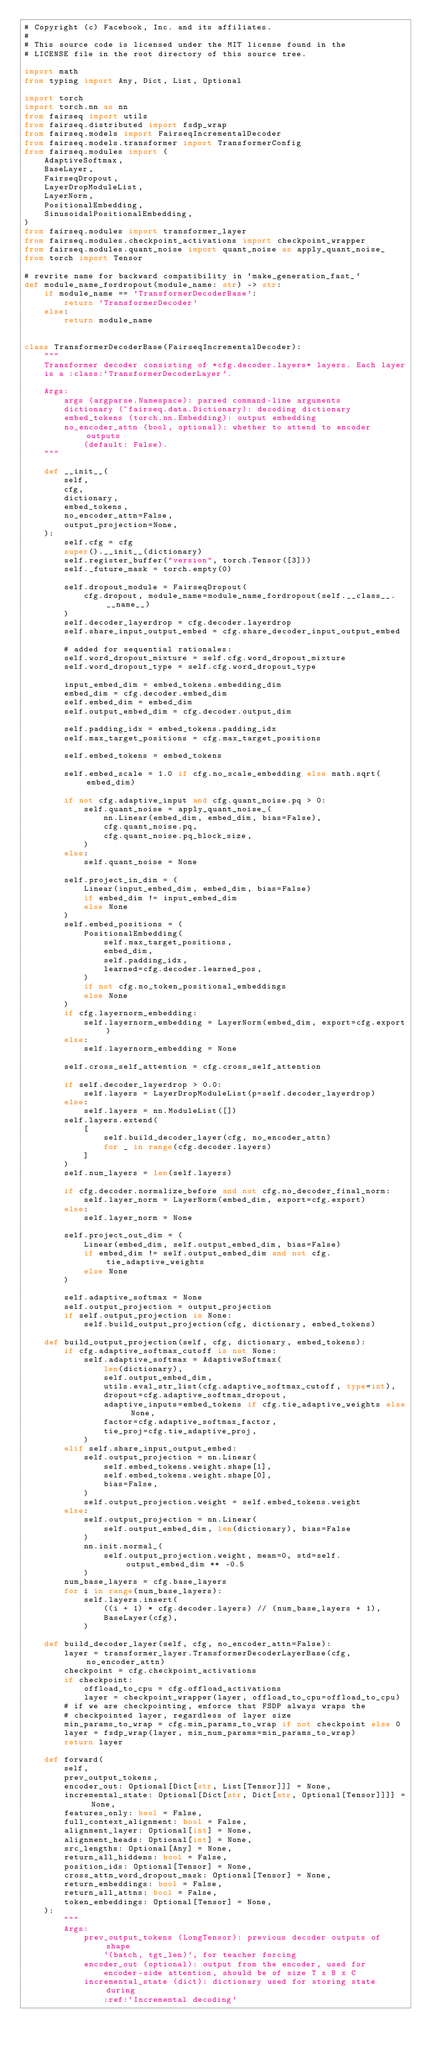<code> <loc_0><loc_0><loc_500><loc_500><_Python_># Copyright (c) Facebook, Inc. and its affiliates.
#
# This source code is licensed under the MIT license found in the
# LICENSE file in the root directory of this source tree.

import math
from typing import Any, Dict, List, Optional

import torch
import torch.nn as nn
from fairseq import utils
from fairseq.distributed import fsdp_wrap
from fairseq.models import FairseqIncrementalDecoder
from fairseq.models.transformer import TransformerConfig
from fairseq.modules import (
    AdaptiveSoftmax,
    BaseLayer,
    FairseqDropout,
    LayerDropModuleList,
    LayerNorm,
    PositionalEmbedding,
    SinusoidalPositionalEmbedding,
)
from fairseq.modules import transformer_layer
from fairseq.modules.checkpoint_activations import checkpoint_wrapper
from fairseq.modules.quant_noise import quant_noise as apply_quant_noise_
from torch import Tensor

# rewrite name for backward compatibility in `make_generation_fast_`
def module_name_fordropout(module_name: str) -> str:
    if module_name == 'TransformerDecoderBase':
        return 'TransformerDecoder'
    else:
        return module_name


class TransformerDecoderBase(FairseqIncrementalDecoder):
    """
    Transformer decoder consisting of *cfg.decoder.layers* layers. Each layer
    is a :class:`TransformerDecoderLayer`.

    Args:
        args (argparse.Namespace): parsed command-line arguments
        dictionary (~fairseq.data.Dictionary): decoding dictionary
        embed_tokens (torch.nn.Embedding): output embedding
        no_encoder_attn (bool, optional): whether to attend to encoder outputs
            (default: False).
    """

    def __init__(
        self,
        cfg,
        dictionary,
        embed_tokens,
        no_encoder_attn=False,
        output_projection=None,
    ):
        self.cfg = cfg
        super().__init__(dictionary)
        self.register_buffer("version", torch.Tensor([3]))
        self._future_mask = torch.empty(0)

        self.dropout_module = FairseqDropout(
            cfg.dropout, module_name=module_name_fordropout(self.__class__.__name__)
        )
        self.decoder_layerdrop = cfg.decoder.layerdrop
        self.share_input_output_embed = cfg.share_decoder_input_output_embed

        # added for sequential rationales:
        self.word_dropout_mixture = self.cfg.word_dropout_mixture
        self.word_dropout_type = self.cfg.word_dropout_type

        input_embed_dim = embed_tokens.embedding_dim
        embed_dim = cfg.decoder.embed_dim
        self.embed_dim = embed_dim
        self.output_embed_dim = cfg.decoder.output_dim

        self.padding_idx = embed_tokens.padding_idx
        self.max_target_positions = cfg.max_target_positions

        self.embed_tokens = embed_tokens

        self.embed_scale = 1.0 if cfg.no_scale_embedding else math.sqrt(embed_dim)

        if not cfg.adaptive_input and cfg.quant_noise.pq > 0:
            self.quant_noise = apply_quant_noise_(
                nn.Linear(embed_dim, embed_dim, bias=False),
                cfg.quant_noise.pq,
                cfg.quant_noise.pq_block_size,
            )
        else:
            self.quant_noise = None

        self.project_in_dim = (
            Linear(input_embed_dim, embed_dim, bias=False)
            if embed_dim != input_embed_dim
            else None
        )
        self.embed_positions = (
            PositionalEmbedding(
                self.max_target_positions,
                embed_dim,
                self.padding_idx,
                learned=cfg.decoder.learned_pos,
            )
            if not cfg.no_token_positional_embeddings
            else None
        )
        if cfg.layernorm_embedding:
            self.layernorm_embedding = LayerNorm(embed_dim, export=cfg.export)
        else:
            self.layernorm_embedding = None

        self.cross_self_attention = cfg.cross_self_attention

        if self.decoder_layerdrop > 0.0:
            self.layers = LayerDropModuleList(p=self.decoder_layerdrop)
        else:
            self.layers = nn.ModuleList([])
        self.layers.extend(
            [
                self.build_decoder_layer(cfg, no_encoder_attn)
                for _ in range(cfg.decoder.layers)
            ]
        )
        self.num_layers = len(self.layers)

        if cfg.decoder.normalize_before and not cfg.no_decoder_final_norm:
            self.layer_norm = LayerNorm(embed_dim, export=cfg.export)
        else:
            self.layer_norm = None

        self.project_out_dim = (
            Linear(embed_dim, self.output_embed_dim, bias=False)
            if embed_dim != self.output_embed_dim and not cfg.tie_adaptive_weights
            else None
        )

        self.adaptive_softmax = None
        self.output_projection = output_projection
        if self.output_projection is None:
            self.build_output_projection(cfg, dictionary, embed_tokens)

    def build_output_projection(self, cfg, dictionary, embed_tokens):
        if cfg.adaptive_softmax_cutoff is not None:
            self.adaptive_softmax = AdaptiveSoftmax(
                len(dictionary),
                self.output_embed_dim,
                utils.eval_str_list(cfg.adaptive_softmax_cutoff, type=int),
                dropout=cfg.adaptive_softmax_dropout,
                adaptive_inputs=embed_tokens if cfg.tie_adaptive_weights else None,
                factor=cfg.adaptive_softmax_factor,
                tie_proj=cfg.tie_adaptive_proj,
            )
        elif self.share_input_output_embed:
            self.output_projection = nn.Linear(
                self.embed_tokens.weight.shape[1],
                self.embed_tokens.weight.shape[0],
                bias=False,
            )
            self.output_projection.weight = self.embed_tokens.weight
        else:
            self.output_projection = nn.Linear(
                self.output_embed_dim, len(dictionary), bias=False
            )
            nn.init.normal_(
                self.output_projection.weight, mean=0, std=self.output_embed_dim ** -0.5
            )
        num_base_layers = cfg.base_layers
        for i in range(num_base_layers):
            self.layers.insert(
                ((i + 1) * cfg.decoder.layers) // (num_base_layers + 1),
                BaseLayer(cfg),
            )

    def build_decoder_layer(self, cfg, no_encoder_attn=False):
        layer = transformer_layer.TransformerDecoderLayerBase(cfg, no_encoder_attn)
        checkpoint = cfg.checkpoint_activations
        if checkpoint:
            offload_to_cpu = cfg.offload_activations
            layer = checkpoint_wrapper(layer, offload_to_cpu=offload_to_cpu)
        # if we are checkpointing, enforce that FSDP always wraps the
        # checkpointed layer, regardless of layer size
        min_params_to_wrap = cfg.min_params_to_wrap if not checkpoint else 0
        layer = fsdp_wrap(layer, min_num_params=min_params_to_wrap)
        return layer

    def forward(
        self,
        prev_output_tokens,
        encoder_out: Optional[Dict[str, List[Tensor]]] = None,
        incremental_state: Optional[Dict[str, Dict[str, Optional[Tensor]]]] = None,
        features_only: bool = False,
        full_context_alignment: bool = False,
        alignment_layer: Optional[int] = None,
        alignment_heads: Optional[int] = None,
        src_lengths: Optional[Any] = None,
        return_all_hiddens: bool = False,
        position_ids: Optional[Tensor] = None,
        cross_attn_word_dropout_mask: Optional[Tensor] = None,
        return_embeddings: bool = False,
        return_all_attns: bool = False,
        token_embeddings: Optional[Tensor] = None,
    ):
        """
        Args:
            prev_output_tokens (LongTensor): previous decoder outputs of shape
                `(batch, tgt_len)`, for teacher forcing
            encoder_out (optional): output from the encoder, used for
                encoder-side attention, should be of size T x B x C
            incremental_state (dict): dictionary used for storing state during
                :ref:`Incremental decoding`</code> 